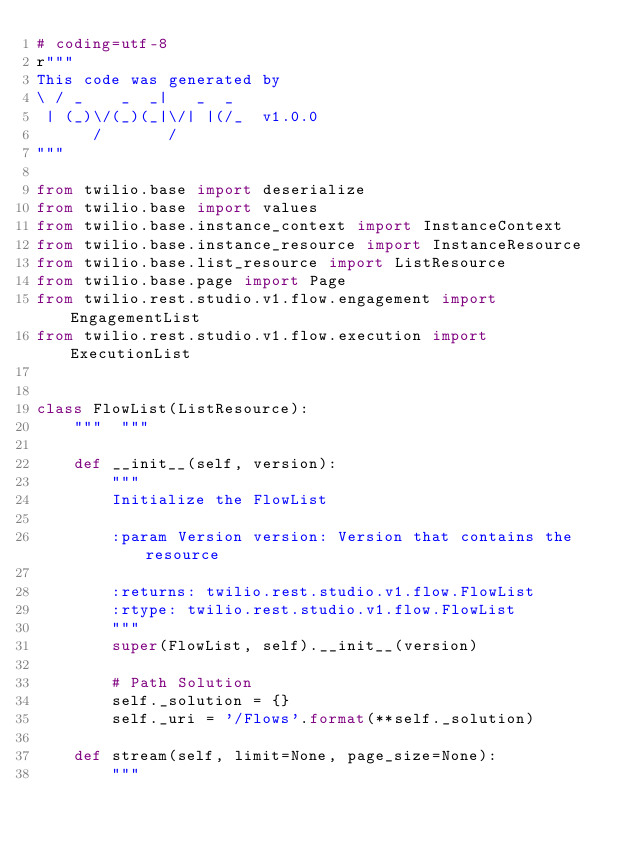<code> <loc_0><loc_0><loc_500><loc_500><_Python_># coding=utf-8
r"""
This code was generated by
\ / _    _  _|   _  _
 | (_)\/(_)(_|\/| |(/_  v1.0.0
      /       /
"""

from twilio.base import deserialize
from twilio.base import values
from twilio.base.instance_context import InstanceContext
from twilio.base.instance_resource import InstanceResource
from twilio.base.list_resource import ListResource
from twilio.base.page import Page
from twilio.rest.studio.v1.flow.engagement import EngagementList
from twilio.rest.studio.v1.flow.execution import ExecutionList


class FlowList(ListResource):
    """  """

    def __init__(self, version):
        """
        Initialize the FlowList

        :param Version version: Version that contains the resource

        :returns: twilio.rest.studio.v1.flow.FlowList
        :rtype: twilio.rest.studio.v1.flow.FlowList
        """
        super(FlowList, self).__init__(version)

        # Path Solution
        self._solution = {}
        self._uri = '/Flows'.format(**self._solution)

    def stream(self, limit=None, page_size=None):
        """</code> 